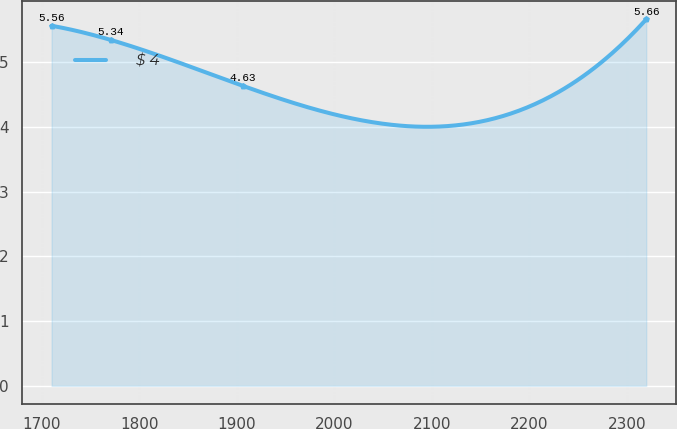Convert chart. <chart><loc_0><loc_0><loc_500><loc_500><line_chart><ecel><fcel>$ 4<nl><fcel>1710.19<fcel>5.56<nl><fcel>1771.16<fcel>5.34<nl><fcel>1906.74<fcel>4.63<nl><fcel>2319.94<fcel>5.66<nl></chart> 